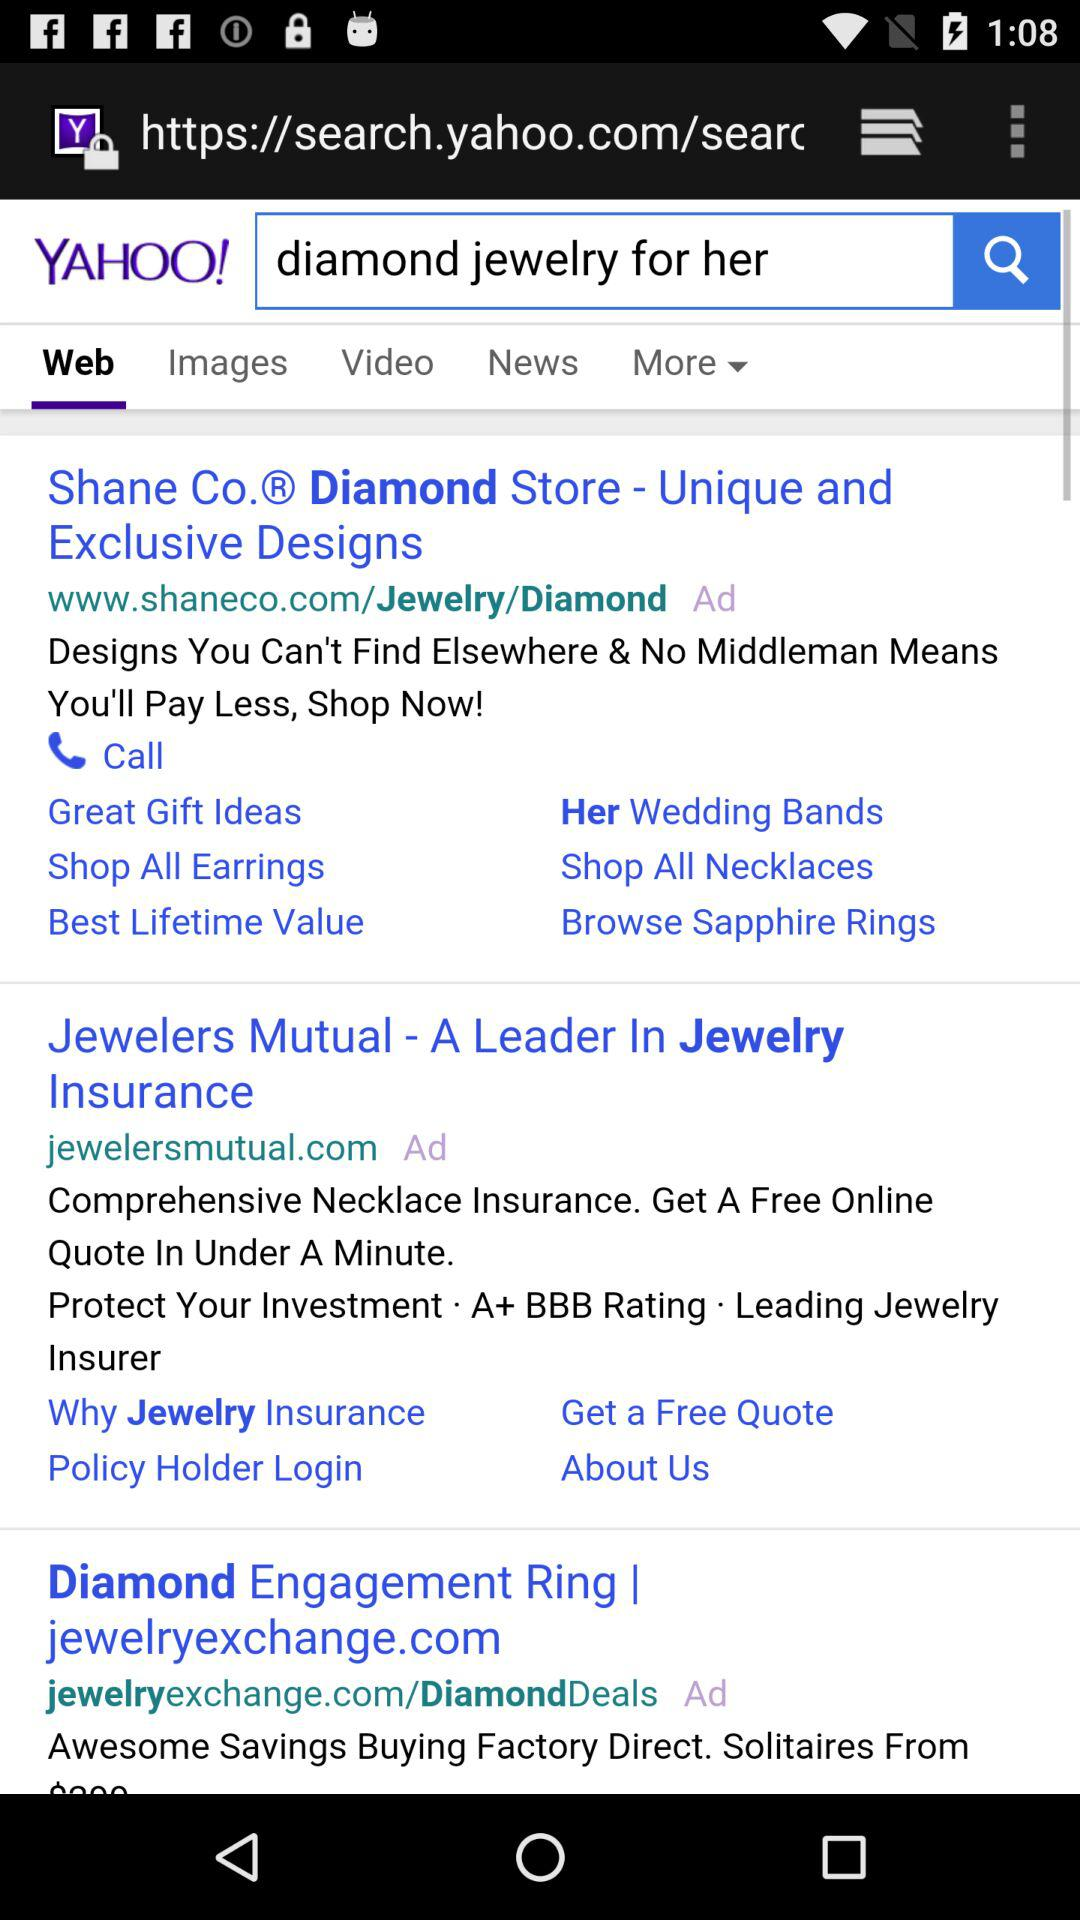How many results are there for the search 'diamond jewelry for her' that have the ad label?
Answer the question using a single word or phrase. 3 